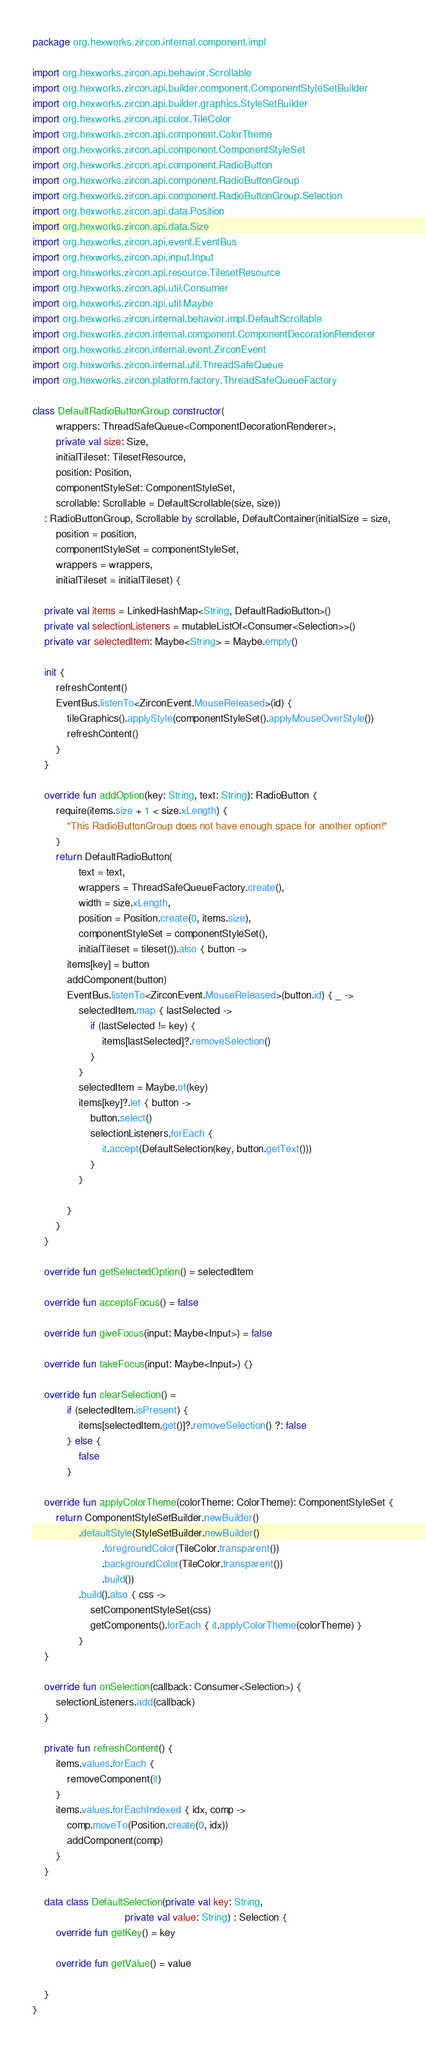Convert code to text. <code><loc_0><loc_0><loc_500><loc_500><_Kotlin_>package org.hexworks.zircon.internal.component.impl

import org.hexworks.zircon.api.behavior.Scrollable
import org.hexworks.zircon.api.builder.component.ComponentStyleSetBuilder
import org.hexworks.zircon.api.builder.graphics.StyleSetBuilder
import org.hexworks.zircon.api.color.TileColor
import org.hexworks.zircon.api.component.ColorTheme
import org.hexworks.zircon.api.component.ComponentStyleSet
import org.hexworks.zircon.api.component.RadioButton
import org.hexworks.zircon.api.component.RadioButtonGroup
import org.hexworks.zircon.api.component.RadioButtonGroup.Selection
import org.hexworks.zircon.api.data.Position
import org.hexworks.zircon.api.data.Size
import org.hexworks.zircon.api.event.EventBus
import org.hexworks.zircon.api.input.Input
import org.hexworks.zircon.api.resource.TilesetResource
import org.hexworks.zircon.api.util.Consumer
import org.hexworks.zircon.api.util.Maybe
import org.hexworks.zircon.internal.behavior.impl.DefaultScrollable
import org.hexworks.zircon.internal.component.ComponentDecorationRenderer
import org.hexworks.zircon.internal.event.ZirconEvent
import org.hexworks.zircon.internal.util.ThreadSafeQueue
import org.hexworks.zircon.platform.factory.ThreadSafeQueueFactory

class DefaultRadioButtonGroup constructor(
        wrappers: ThreadSafeQueue<ComponentDecorationRenderer>,
        private val size: Size,
        initialTileset: TilesetResource,
        position: Position,
        componentStyleSet: ComponentStyleSet,
        scrollable: Scrollable = DefaultScrollable(size, size))
    : RadioButtonGroup, Scrollable by scrollable, DefaultContainer(initialSize = size,
        position = position,
        componentStyleSet = componentStyleSet,
        wrappers = wrappers,
        initialTileset = initialTileset) {

    private val items = LinkedHashMap<String, DefaultRadioButton>()
    private val selectionListeners = mutableListOf<Consumer<Selection>>()
    private var selectedItem: Maybe<String> = Maybe.empty()

    init {
        refreshContent()
        EventBus.listenTo<ZirconEvent.MouseReleased>(id) {
            tileGraphics().applyStyle(componentStyleSet().applyMouseOverStyle())
            refreshContent()
        }
    }

    override fun addOption(key: String, text: String): RadioButton {
        require(items.size + 1 < size.xLength) {
            "This RadioButtonGroup does not have enough space for another option!"
        }
        return DefaultRadioButton(
                text = text,
                wrappers = ThreadSafeQueueFactory.create(),
                width = size.xLength,
                position = Position.create(0, items.size),
                componentStyleSet = componentStyleSet(),
                initialTileset = tileset()).also { button ->
            items[key] = button
            addComponent(button)
            EventBus.listenTo<ZirconEvent.MouseReleased>(button.id) { _ ->
                selectedItem.map { lastSelected ->
                    if (lastSelected != key) {
                        items[lastSelected]?.removeSelection()
                    }
                }
                selectedItem = Maybe.of(key)
                items[key]?.let { button ->
                    button.select()
                    selectionListeners.forEach {
                        it.accept(DefaultSelection(key, button.getText()))
                    }
                }

            }
        }
    }

    override fun getSelectedOption() = selectedItem

    override fun acceptsFocus() = false

    override fun giveFocus(input: Maybe<Input>) = false

    override fun takeFocus(input: Maybe<Input>) {}

    override fun clearSelection() =
            if (selectedItem.isPresent) {
                items[selectedItem.get()]?.removeSelection() ?: false
            } else {
                false
            }

    override fun applyColorTheme(colorTheme: ColorTheme): ComponentStyleSet {
        return ComponentStyleSetBuilder.newBuilder()
                .defaultStyle(StyleSetBuilder.newBuilder()
                        .foregroundColor(TileColor.transparent())
                        .backgroundColor(TileColor.transparent())
                        .build())
                .build().also { css ->
                    setComponentStyleSet(css)
                    getComponents().forEach { it.applyColorTheme(colorTheme) }
                }
    }

    override fun onSelection(callback: Consumer<Selection>) {
        selectionListeners.add(callback)
    }

    private fun refreshContent() {
        items.values.forEach {
            removeComponent(it)
        }
        items.values.forEachIndexed { idx, comp ->
            comp.moveTo(Position.create(0, idx))
            addComponent(comp)
        }
    }

    data class DefaultSelection(private val key: String,
                                private val value: String) : Selection {
        override fun getKey() = key

        override fun getValue() = value

    }
}
</code> 